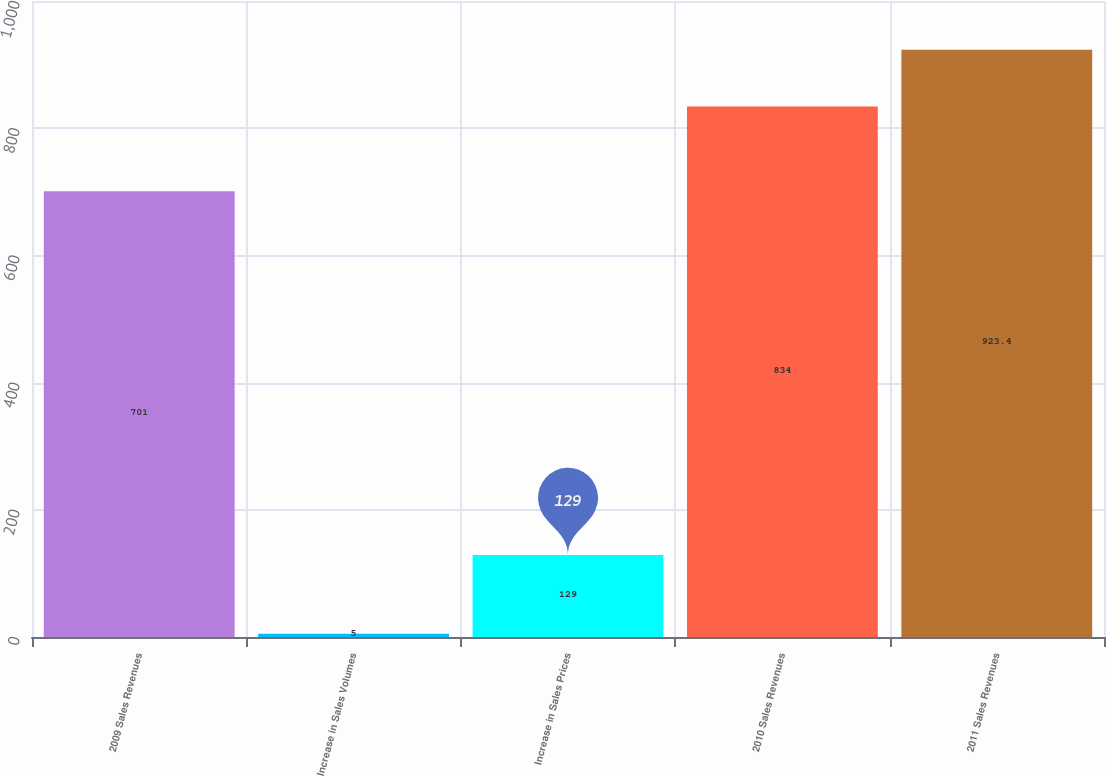Convert chart to OTSL. <chart><loc_0><loc_0><loc_500><loc_500><bar_chart><fcel>2009 Sales Revenues<fcel>Increase in Sales Volumes<fcel>Increase in Sales Prices<fcel>2010 Sales Revenues<fcel>2011 Sales Revenues<nl><fcel>701<fcel>5<fcel>129<fcel>834<fcel>923.4<nl></chart> 